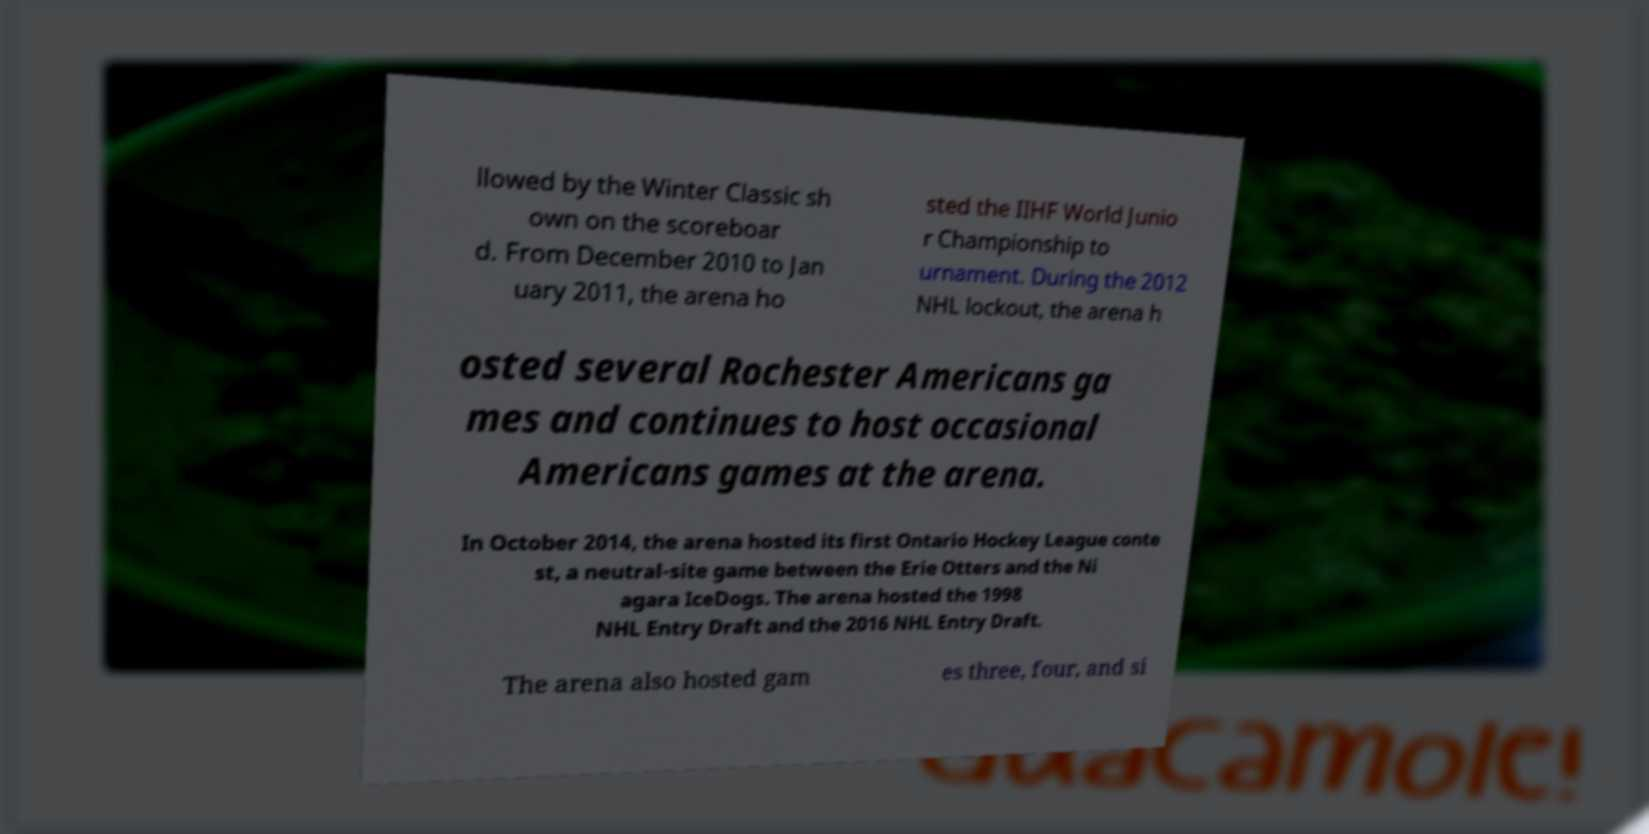Could you extract and type out the text from this image? llowed by the Winter Classic sh own on the scoreboar d. From December 2010 to Jan uary 2011, the arena ho sted the IIHF World Junio r Championship to urnament. During the 2012 NHL lockout, the arena h osted several Rochester Americans ga mes and continues to host occasional Americans games at the arena. In October 2014, the arena hosted its first Ontario Hockey League conte st, a neutral-site game between the Erie Otters and the Ni agara IceDogs. The arena hosted the 1998 NHL Entry Draft and the 2016 NHL Entry Draft. The arena also hosted gam es three, four, and si 